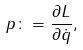Convert formula to latex. <formula><loc_0><loc_0><loc_500><loc_500>p \colon = \frac { \partial L } { \partial \dot { q } } ,</formula> 